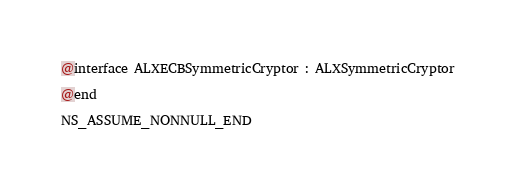Convert code to text. <code><loc_0><loc_0><loc_500><loc_500><_C_>
@interface ALXECBSymmetricCryptor : ALXSymmetricCryptor

@end

NS_ASSUME_NONNULL_END
</code> 